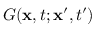<formula> <loc_0><loc_0><loc_500><loc_500>G ( x , t ; x ^ { \prime } , t ^ { \prime } )</formula> 